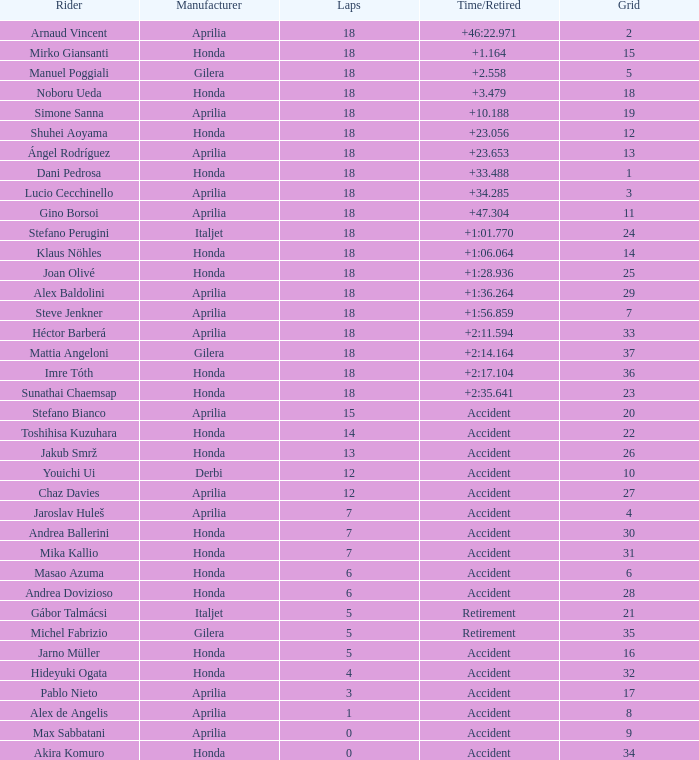Give me the full table as a dictionary. {'header': ['Rider', 'Manufacturer', 'Laps', 'Time/Retired', 'Grid'], 'rows': [['Arnaud Vincent', 'Aprilia', '18', '+46:22.971', '2'], ['Mirko Giansanti', 'Honda', '18', '+1.164', '15'], ['Manuel Poggiali', 'Gilera', '18', '+2.558', '5'], ['Noboru Ueda', 'Honda', '18', '+3.479', '18'], ['Simone Sanna', 'Aprilia', '18', '+10.188', '19'], ['Shuhei Aoyama', 'Honda', '18', '+23.056', '12'], ['Ángel Rodríguez', 'Aprilia', '18', '+23.653', '13'], ['Dani Pedrosa', 'Honda', '18', '+33.488', '1'], ['Lucio Cecchinello', 'Aprilia', '18', '+34.285', '3'], ['Gino Borsoi', 'Aprilia', '18', '+47.304', '11'], ['Stefano Perugini', 'Italjet', '18', '+1:01.770', '24'], ['Klaus Nöhles', 'Honda', '18', '+1:06.064', '14'], ['Joan Olivé', 'Honda', '18', '+1:28.936', '25'], ['Alex Baldolini', 'Aprilia', '18', '+1:36.264', '29'], ['Steve Jenkner', 'Aprilia', '18', '+1:56.859', '7'], ['Héctor Barberá', 'Aprilia', '18', '+2:11.594', '33'], ['Mattia Angeloni', 'Gilera', '18', '+2:14.164', '37'], ['Imre Tóth', 'Honda', '18', '+2:17.104', '36'], ['Sunathai Chaemsap', 'Honda', '18', '+2:35.641', '23'], ['Stefano Bianco', 'Aprilia', '15', 'Accident', '20'], ['Toshihisa Kuzuhara', 'Honda', '14', 'Accident', '22'], ['Jakub Smrž', 'Honda', '13', 'Accident', '26'], ['Youichi Ui', 'Derbi', '12', 'Accident', '10'], ['Chaz Davies', 'Aprilia', '12', 'Accident', '27'], ['Jaroslav Huleš', 'Aprilia', '7', 'Accident', '4'], ['Andrea Ballerini', 'Honda', '7', 'Accident', '30'], ['Mika Kallio', 'Honda', '7', 'Accident', '31'], ['Masao Azuma', 'Honda', '6', 'Accident', '6'], ['Andrea Dovizioso', 'Honda', '6', 'Accident', '28'], ['Gábor Talmácsi', 'Italjet', '5', 'Retirement', '21'], ['Michel Fabrizio', 'Gilera', '5', 'Retirement', '35'], ['Jarno Müller', 'Honda', '5', 'Accident', '16'], ['Hideyuki Ogata', 'Honda', '4', 'Accident', '32'], ['Pablo Nieto', 'Aprilia', '3', 'Accident', '17'], ['Alex de Angelis', 'Aprilia', '1', 'Accident', '8'], ['Max Sabbatani', 'Aprilia', '0', 'Accident', '9'], ['Akira Komuro', 'Honda', '0', 'Accident', '34']]} What is the average number of laps with an accident time/retired, aprilia manufacturer and a grid of 27? 12.0. 